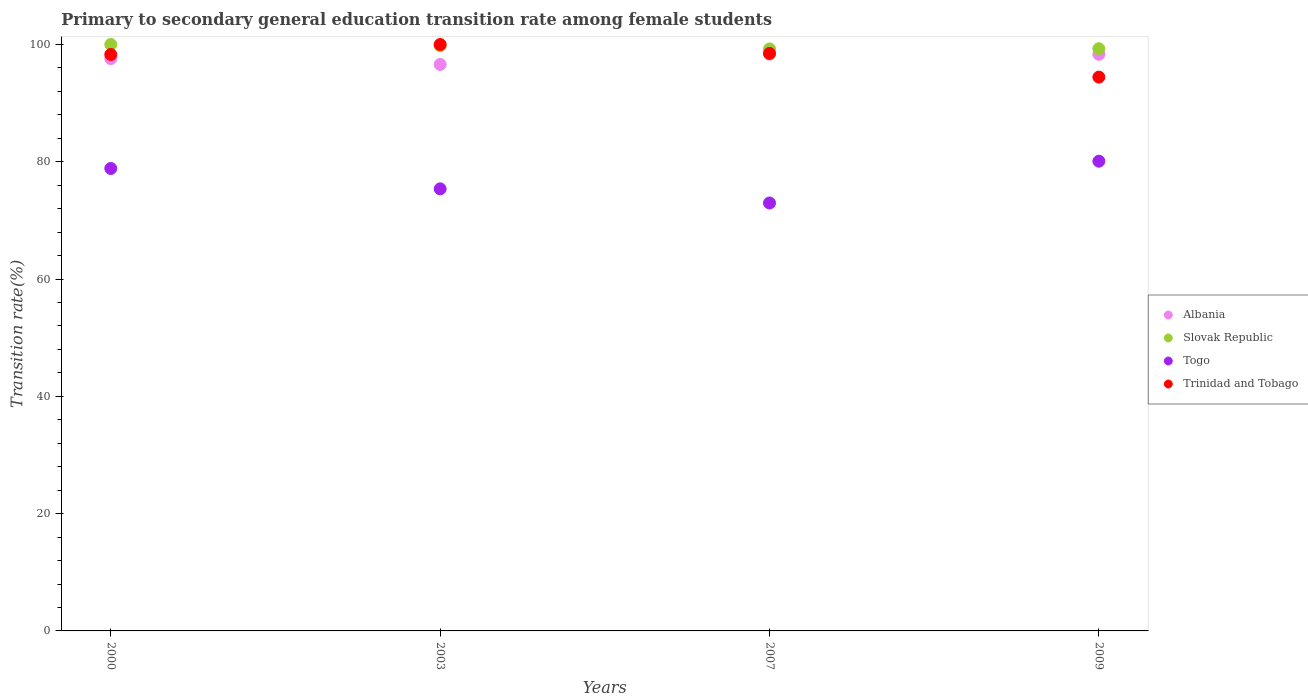How many different coloured dotlines are there?
Provide a succinct answer. 4. What is the transition rate in Togo in 2009?
Offer a terse response. 80.1. Across all years, what is the minimum transition rate in Togo?
Your answer should be compact. 72.97. In which year was the transition rate in Trinidad and Tobago maximum?
Give a very brief answer. 2003. In which year was the transition rate in Togo minimum?
Your response must be concise. 2007. What is the total transition rate in Trinidad and Tobago in the graph?
Provide a succinct answer. 391.22. What is the difference between the transition rate in Slovak Republic in 2000 and that in 2003?
Your answer should be very brief. 0.22. What is the difference between the transition rate in Togo in 2000 and the transition rate in Albania in 2009?
Give a very brief answer. -19.48. What is the average transition rate in Slovak Republic per year?
Keep it short and to the point. 99.58. In the year 2007, what is the difference between the transition rate in Togo and transition rate in Trinidad and Tobago?
Offer a very short reply. -25.51. In how many years, is the transition rate in Togo greater than 24 %?
Your response must be concise. 4. What is the ratio of the transition rate in Togo in 2007 to that in 2009?
Keep it short and to the point. 0.91. Is the transition rate in Trinidad and Tobago in 2000 less than that in 2007?
Your answer should be very brief. Yes. What is the difference between the highest and the second highest transition rate in Albania?
Give a very brief answer. 0.03. What is the difference between the highest and the lowest transition rate in Slovak Republic?
Keep it short and to the point. 0.75. Is the sum of the transition rate in Trinidad and Tobago in 2003 and 2009 greater than the maximum transition rate in Albania across all years?
Your answer should be compact. Yes. Is it the case that in every year, the sum of the transition rate in Togo and transition rate in Slovak Republic  is greater than the sum of transition rate in Albania and transition rate in Trinidad and Tobago?
Provide a short and direct response. No. Is it the case that in every year, the sum of the transition rate in Slovak Republic and transition rate in Albania  is greater than the transition rate in Togo?
Provide a short and direct response. Yes. Is the transition rate in Slovak Republic strictly less than the transition rate in Albania over the years?
Provide a succinct answer. No. How many years are there in the graph?
Provide a succinct answer. 4. What is the difference between two consecutive major ticks on the Y-axis?
Ensure brevity in your answer.  20. Are the values on the major ticks of Y-axis written in scientific E-notation?
Make the answer very short. No. How are the legend labels stacked?
Make the answer very short. Vertical. What is the title of the graph?
Your response must be concise. Primary to secondary general education transition rate among female students. Does "Nepal" appear as one of the legend labels in the graph?
Your answer should be very brief. No. What is the label or title of the X-axis?
Provide a short and direct response. Years. What is the label or title of the Y-axis?
Make the answer very short. Transition rate(%). What is the Transition rate(%) in Albania in 2000?
Your answer should be very brief. 97.6. What is the Transition rate(%) of Togo in 2000?
Your answer should be compact. 78.86. What is the Transition rate(%) of Trinidad and Tobago in 2000?
Your answer should be compact. 98.3. What is the Transition rate(%) of Albania in 2003?
Give a very brief answer. 96.59. What is the Transition rate(%) of Slovak Republic in 2003?
Offer a very short reply. 99.78. What is the Transition rate(%) of Togo in 2003?
Keep it short and to the point. 75.39. What is the Transition rate(%) of Trinidad and Tobago in 2003?
Make the answer very short. 100. What is the Transition rate(%) of Albania in 2007?
Provide a short and direct response. 98.36. What is the Transition rate(%) of Slovak Republic in 2007?
Offer a very short reply. 99.25. What is the Transition rate(%) in Togo in 2007?
Ensure brevity in your answer.  72.97. What is the Transition rate(%) of Trinidad and Tobago in 2007?
Offer a very short reply. 98.48. What is the Transition rate(%) in Albania in 2009?
Your answer should be compact. 98.33. What is the Transition rate(%) of Slovak Republic in 2009?
Offer a very short reply. 99.28. What is the Transition rate(%) in Togo in 2009?
Offer a very short reply. 80.1. What is the Transition rate(%) in Trinidad and Tobago in 2009?
Your answer should be compact. 94.44. Across all years, what is the maximum Transition rate(%) of Albania?
Make the answer very short. 98.36. Across all years, what is the maximum Transition rate(%) of Slovak Republic?
Make the answer very short. 100. Across all years, what is the maximum Transition rate(%) in Togo?
Your response must be concise. 80.1. Across all years, what is the minimum Transition rate(%) in Albania?
Offer a terse response. 96.59. Across all years, what is the minimum Transition rate(%) in Slovak Republic?
Your answer should be very brief. 99.25. Across all years, what is the minimum Transition rate(%) in Togo?
Your answer should be very brief. 72.97. Across all years, what is the minimum Transition rate(%) of Trinidad and Tobago?
Give a very brief answer. 94.44. What is the total Transition rate(%) of Albania in the graph?
Provide a short and direct response. 390.88. What is the total Transition rate(%) of Slovak Republic in the graph?
Keep it short and to the point. 398.31. What is the total Transition rate(%) of Togo in the graph?
Provide a short and direct response. 307.32. What is the total Transition rate(%) in Trinidad and Tobago in the graph?
Your answer should be very brief. 391.22. What is the difference between the Transition rate(%) in Slovak Republic in 2000 and that in 2003?
Give a very brief answer. 0.22. What is the difference between the Transition rate(%) of Togo in 2000 and that in 2003?
Keep it short and to the point. 3.47. What is the difference between the Transition rate(%) of Trinidad and Tobago in 2000 and that in 2003?
Ensure brevity in your answer.  -1.7. What is the difference between the Transition rate(%) in Albania in 2000 and that in 2007?
Offer a very short reply. -0.77. What is the difference between the Transition rate(%) in Slovak Republic in 2000 and that in 2007?
Offer a very short reply. 0.75. What is the difference between the Transition rate(%) of Togo in 2000 and that in 2007?
Ensure brevity in your answer.  5.88. What is the difference between the Transition rate(%) of Trinidad and Tobago in 2000 and that in 2007?
Give a very brief answer. -0.19. What is the difference between the Transition rate(%) of Albania in 2000 and that in 2009?
Ensure brevity in your answer.  -0.74. What is the difference between the Transition rate(%) of Slovak Republic in 2000 and that in 2009?
Provide a short and direct response. 0.72. What is the difference between the Transition rate(%) of Togo in 2000 and that in 2009?
Your answer should be compact. -1.24. What is the difference between the Transition rate(%) in Trinidad and Tobago in 2000 and that in 2009?
Provide a short and direct response. 3.86. What is the difference between the Transition rate(%) in Albania in 2003 and that in 2007?
Keep it short and to the point. -1.77. What is the difference between the Transition rate(%) of Slovak Republic in 2003 and that in 2007?
Offer a terse response. 0.53. What is the difference between the Transition rate(%) in Togo in 2003 and that in 2007?
Your response must be concise. 2.41. What is the difference between the Transition rate(%) of Trinidad and Tobago in 2003 and that in 2007?
Offer a very short reply. 1.52. What is the difference between the Transition rate(%) of Albania in 2003 and that in 2009?
Give a very brief answer. -1.74. What is the difference between the Transition rate(%) of Slovak Republic in 2003 and that in 2009?
Give a very brief answer. 0.5. What is the difference between the Transition rate(%) in Togo in 2003 and that in 2009?
Provide a short and direct response. -4.71. What is the difference between the Transition rate(%) in Trinidad and Tobago in 2003 and that in 2009?
Give a very brief answer. 5.56. What is the difference between the Transition rate(%) in Albania in 2007 and that in 2009?
Your answer should be very brief. 0.03. What is the difference between the Transition rate(%) of Slovak Republic in 2007 and that in 2009?
Give a very brief answer. -0.03. What is the difference between the Transition rate(%) in Togo in 2007 and that in 2009?
Make the answer very short. -7.12. What is the difference between the Transition rate(%) in Trinidad and Tobago in 2007 and that in 2009?
Offer a terse response. 4.05. What is the difference between the Transition rate(%) in Albania in 2000 and the Transition rate(%) in Slovak Republic in 2003?
Offer a very short reply. -2.18. What is the difference between the Transition rate(%) of Albania in 2000 and the Transition rate(%) of Togo in 2003?
Ensure brevity in your answer.  22.21. What is the difference between the Transition rate(%) of Albania in 2000 and the Transition rate(%) of Trinidad and Tobago in 2003?
Offer a terse response. -2.4. What is the difference between the Transition rate(%) in Slovak Republic in 2000 and the Transition rate(%) in Togo in 2003?
Make the answer very short. 24.61. What is the difference between the Transition rate(%) of Togo in 2000 and the Transition rate(%) of Trinidad and Tobago in 2003?
Make the answer very short. -21.14. What is the difference between the Transition rate(%) of Albania in 2000 and the Transition rate(%) of Slovak Republic in 2007?
Offer a very short reply. -1.65. What is the difference between the Transition rate(%) of Albania in 2000 and the Transition rate(%) of Togo in 2007?
Your answer should be very brief. 24.62. What is the difference between the Transition rate(%) in Albania in 2000 and the Transition rate(%) in Trinidad and Tobago in 2007?
Keep it short and to the point. -0.89. What is the difference between the Transition rate(%) in Slovak Republic in 2000 and the Transition rate(%) in Togo in 2007?
Your answer should be very brief. 27.03. What is the difference between the Transition rate(%) of Slovak Republic in 2000 and the Transition rate(%) of Trinidad and Tobago in 2007?
Your response must be concise. 1.52. What is the difference between the Transition rate(%) in Togo in 2000 and the Transition rate(%) in Trinidad and Tobago in 2007?
Give a very brief answer. -19.63. What is the difference between the Transition rate(%) of Albania in 2000 and the Transition rate(%) of Slovak Republic in 2009?
Offer a very short reply. -1.69. What is the difference between the Transition rate(%) of Albania in 2000 and the Transition rate(%) of Togo in 2009?
Offer a very short reply. 17.5. What is the difference between the Transition rate(%) of Albania in 2000 and the Transition rate(%) of Trinidad and Tobago in 2009?
Your answer should be compact. 3.16. What is the difference between the Transition rate(%) of Slovak Republic in 2000 and the Transition rate(%) of Togo in 2009?
Provide a succinct answer. 19.9. What is the difference between the Transition rate(%) in Slovak Republic in 2000 and the Transition rate(%) in Trinidad and Tobago in 2009?
Your answer should be very brief. 5.56. What is the difference between the Transition rate(%) of Togo in 2000 and the Transition rate(%) of Trinidad and Tobago in 2009?
Provide a succinct answer. -15.58. What is the difference between the Transition rate(%) of Albania in 2003 and the Transition rate(%) of Slovak Republic in 2007?
Ensure brevity in your answer.  -2.66. What is the difference between the Transition rate(%) in Albania in 2003 and the Transition rate(%) in Togo in 2007?
Make the answer very short. 23.62. What is the difference between the Transition rate(%) of Albania in 2003 and the Transition rate(%) of Trinidad and Tobago in 2007?
Offer a terse response. -1.89. What is the difference between the Transition rate(%) of Slovak Republic in 2003 and the Transition rate(%) of Togo in 2007?
Give a very brief answer. 26.81. What is the difference between the Transition rate(%) in Slovak Republic in 2003 and the Transition rate(%) in Trinidad and Tobago in 2007?
Provide a succinct answer. 1.29. What is the difference between the Transition rate(%) of Togo in 2003 and the Transition rate(%) of Trinidad and Tobago in 2007?
Ensure brevity in your answer.  -23.1. What is the difference between the Transition rate(%) in Albania in 2003 and the Transition rate(%) in Slovak Republic in 2009?
Your answer should be compact. -2.69. What is the difference between the Transition rate(%) in Albania in 2003 and the Transition rate(%) in Togo in 2009?
Ensure brevity in your answer.  16.5. What is the difference between the Transition rate(%) in Albania in 2003 and the Transition rate(%) in Trinidad and Tobago in 2009?
Offer a very short reply. 2.15. What is the difference between the Transition rate(%) in Slovak Republic in 2003 and the Transition rate(%) in Togo in 2009?
Make the answer very short. 19.68. What is the difference between the Transition rate(%) of Slovak Republic in 2003 and the Transition rate(%) of Trinidad and Tobago in 2009?
Ensure brevity in your answer.  5.34. What is the difference between the Transition rate(%) in Togo in 2003 and the Transition rate(%) in Trinidad and Tobago in 2009?
Your answer should be very brief. -19.05. What is the difference between the Transition rate(%) of Albania in 2007 and the Transition rate(%) of Slovak Republic in 2009?
Your answer should be very brief. -0.92. What is the difference between the Transition rate(%) of Albania in 2007 and the Transition rate(%) of Togo in 2009?
Your answer should be compact. 18.26. What is the difference between the Transition rate(%) of Albania in 2007 and the Transition rate(%) of Trinidad and Tobago in 2009?
Give a very brief answer. 3.92. What is the difference between the Transition rate(%) in Slovak Republic in 2007 and the Transition rate(%) in Togo in 2009?
Your answer should be very brief. 19.15. What is the difference between the Transition rate(%) in Slovak Republic in 2007 and the Transition rate(%) in Trinidad and Tobago in 2009?
Offer a terse response. 4.81. What is the difference between the Transition rate(%) in Togo in 2007 and the Transition rate(%) in Trinidad and Tobago in 2009?
Your answer should be very brief. -21.46. What is the average Transition rate(%) in Albania per year?
Offer a very short reply. 97.72. What is the average Transition rate(%) in Slovak Republic per year?
Offer a very short reply. 99.58. What is the average Transition rate(%) in Togo per year?
Offer a terse response. 76.83. What is the average Transition rate(%) of Trinidad and Tobago per year?
Your response must be concise. 97.81. In the year 2000, what is the difference between the Transition rate(%) in Albania and Transition rate(%) in Slovak Republic?
Provide a short and direct response. -2.4. In the year 2000, what is the difference between the Transition rate(%) of Albania and Transition rate(%) of Togo?
Your answer should be compact. 18.74. In the year 2000, what is the difference between the Transition rate(%) in Albania and Transition rate(%) in Trinidad and Tobago?
Your answer should be compact. -0.7. In the year 2000, what is the difference between the Transition rate(%) of Slovak Republic and Transition rate(%) of Togo?
Offer a terse response. 21.14. In the year 2000, what is the difference between the Transition rate(%) in Slovak Republic and Transition rate(%) in Trinidad and Tobago?
Your response must be concise. 1.7. In the year 2000, what is the difference between the Transition rate(%) in Togo and Transition rate(%) in Trinidad and Tobago?
Keep it short and to the point. -19.44. In the year 2003, what is the difference between the Transition rate(%) of Albania and Transition rate(%) of Slovak Republic?
Your answer should be very brief. -3.19. In the year 2003, what is the difference between the Transition rate(%) of Albania and Transition rate(%) of Togo?
Give a very brief answer. 21.21. In the year 2003, what is the difference between the Transition rate(%) in Albania and Transition rate(%) in Trinidad and Tobago?
Ensure brevity in your answer.  -3.41. In the year 2003, what is the difference between the Transition rate(%) in Slovak Republic and Transition rate(%) in Togo?
Offer a terse response. 24.39. In the year 2003, what is the difference between the Transition rate(%) of Slovak Republic and Transition rate(%) of Trinidad and Tobago?
Keep it short and to the point. -0.22. In the year 2003, what is the difference between the Transition rate(%) in Togo and Transition rate(%) in Trinidad and Tobago?
Provide a succinct answer. -24.61. In the year 2007, what is the difference between the Transition rate(%) in Albania and Transition rate(%) in Slovak Republic?
Offer a terse response. -0.89. In the year 2007, what is the difference between the Transition rate(%) in Albania and Transition rate(%) in Togo?
Ensure brevity in your answer.  25.39. In the year 2007, what is the difference between the Transition rate(%) in Albania and Transition rate(%) in Trinidad and Tobago?
Ensure brevity in your answer.  -0.12. In the year 2007, what is the difference between the Transition rate(%) in Slovak Republic and Transition rate(%) in Togo?
Offer a very short reply. 26.27. In the year 2007, what is the difference between the Transition rate(%) of Slovak Republic and Transition rate(%) of Trinidad and Tobago?
Ensure brevity in your answer.  0.76. In the year 2007, what is the difference between the Transition rate(%) of Togo and Transition rate(%) of Trinidad and Tobago?
Ensure brevity in your answer.  -25.51. In the year 2009, what is the difference between the Transition rate(%) of Albania and Transition rate(%) of Slovak Republic?
Your answer should be compact. -0.95. In the year 2009, what is the difference between the Transition rate(%) of Albania and Transition rate(%) of Togo?
Offer a terse response. 18.24. In the year 2009, what is the difference between the Transition rate(%) in Albania and Transition rate(%) in Trinidad and Tobago?
Make the answer very short. 3.9. In the year 2009, what is the difference between the Transition rate(%) in Slovak Republic and Transition rate(%) in Togo?
Keep it short and to the point. 19.18. In the year 2009, what is the difference between the Transition rate(%) in Slovak Republic and Transition rate(%) in Trinidad and Tobago?
Offer a very short reply. 4.84. In the year 2009, what is the difference between the Transition rate(%) of Togo and Transition rate(%) of Trinidad and Tobago?
Your answer should be compact. -14.34. What is the ratio of the Transition rate(%) in Albania in 2000 to that in 2003?
Your response must be concise. 1.01. What is the ratio of the Transition rate(%) of Slovak Republic in 2000 to that in 2003?
Provide a succinct answer. 1. What is the ratio of the Transition rate(%) of Togo in 2000 to that in 2003?
Provide a short and direct response. 1.05. What is the ratio of the Transition rate(%) of Trinidad and Tobago in 2000 to that in 2003?
Your answer should be compact. 0.98. What is the ratio of the Transition rate(%) in Albania in 2000 to that in 2007?
Make the answer very short. 0.99. What is the ratio of the Transition rate(%) in Slovak Republic in 2000 to that in 2007?
Ensure brevity in your answer.  1.01. What is the ratio of the Transition rate(%) in Togo in 2000 to that in 2007?
Your response must be concise. 1.08. What is the ratio of the Transition rate(%) of Albania in 2000 to that in 2009?
Offer a terse response. 0.99. What is the ratio of the Transition rate(%) in Togo in 2000 to that in 2009?
Give a very brief answer. 0.98. What is the ratio of the Transition rate(%) in Trinidad and Tobago in 2000 to that in 2009?
Give a very brief answer. 1.04. What is the ratio of the Transition rate(%) in Albania in 2003 to that in 2007?
Offer a very short reply. 0.98. What is the ratio of the Transition rate(%) in Slovak Republic in 2003 to that in 2007?
Offer a terse response. 1.01. What is the ratio of the Transition rate(%) of Togo in 2003 to that in 2007?
Offer a very short reply. 1.03. What is the ratio of the Transition rate(%) of Trinidad and Tobago in 2003 to that in 2007?
Give a very brief answer. 1.02. What is the ratio of the Transition rate(%) of Albania in 2003 to that in 2009?
Provide a succinct answer. 0.98. What is the ratio of the Transition rate(%) in Slovak Republic in 2003 to that in 2009?
Offer a terse response. 1. What is the ratio of the Transition rate(%) in Togo in 2003 to that in 2009?
Your answer should be compact. 0.94. What is the ratio of the Transition rate(%) in Trinidad and Tobago in 2003 to that in 2009?
Ensure brevity in your answer.  1.06. What is the ratio of the Transition rate(%) in Togo in 2007 to that in 2009?
Provide a succinct answer. 0.91. What is the ratio of the Transition rate(%) of Trinidad and Tobago in 2007 to that in 2009?
Ensure brevity in your answer.  1.04. What is the difference between the highest and the second highest Transition rate(%) in Albania?
Your answer should be very brief. 0.03. What is the difference between the highest and the second highest Transition rate(%) of Slovak Republic?
Make the answer very short. 0.22. What is the difference between the highest and the second highest Transition rate(%) in Togo?
Provide a short and direct response. 1.24. What is the difference between the highest and the second highest Transition rate(%) in Trinidad and Tobago?
Your response must be concise. 1.52. What is the difference between the highest and the lowest Transition rate(%) in Albania?
Provide a short and direct response. 1.77. What is the difference between the highest and the lowest Transition rate(%) of Slovak Republic?
Ensure brevity in your answer.  0.75. What is the difference between the highest and the lowest Transition rate(%) in Togo?
Offer a terse response. 7.12. What is the difference between the highest and the lowest Transition rate(%) in Trinidad and Tobago?
Provide a succinct answer. 5.56. 